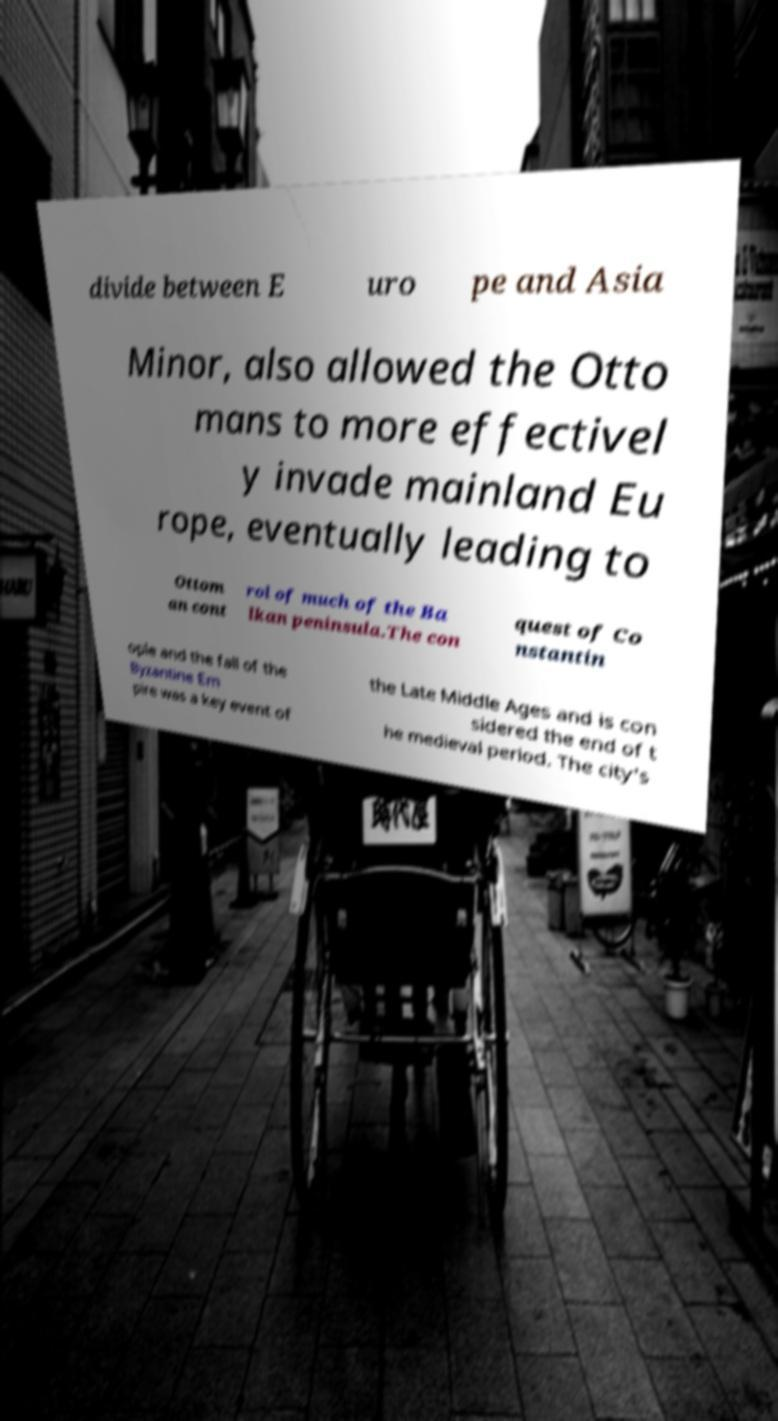What messages or text are displayed in this image? I need them in a readable, typed format. divide between E uro pe and Asia Minor, also allowed the Otto mans to more effectivel y invade mainland Eu rope, eventually leading to Ottom an cont rol of much of the Ba lkan peninsula.The con quest of Co nstantin ople and the fall of the Byzantine Em pire was a key event of the Late Middle Ages and is con sidered the end of t he medieval period. The city's 